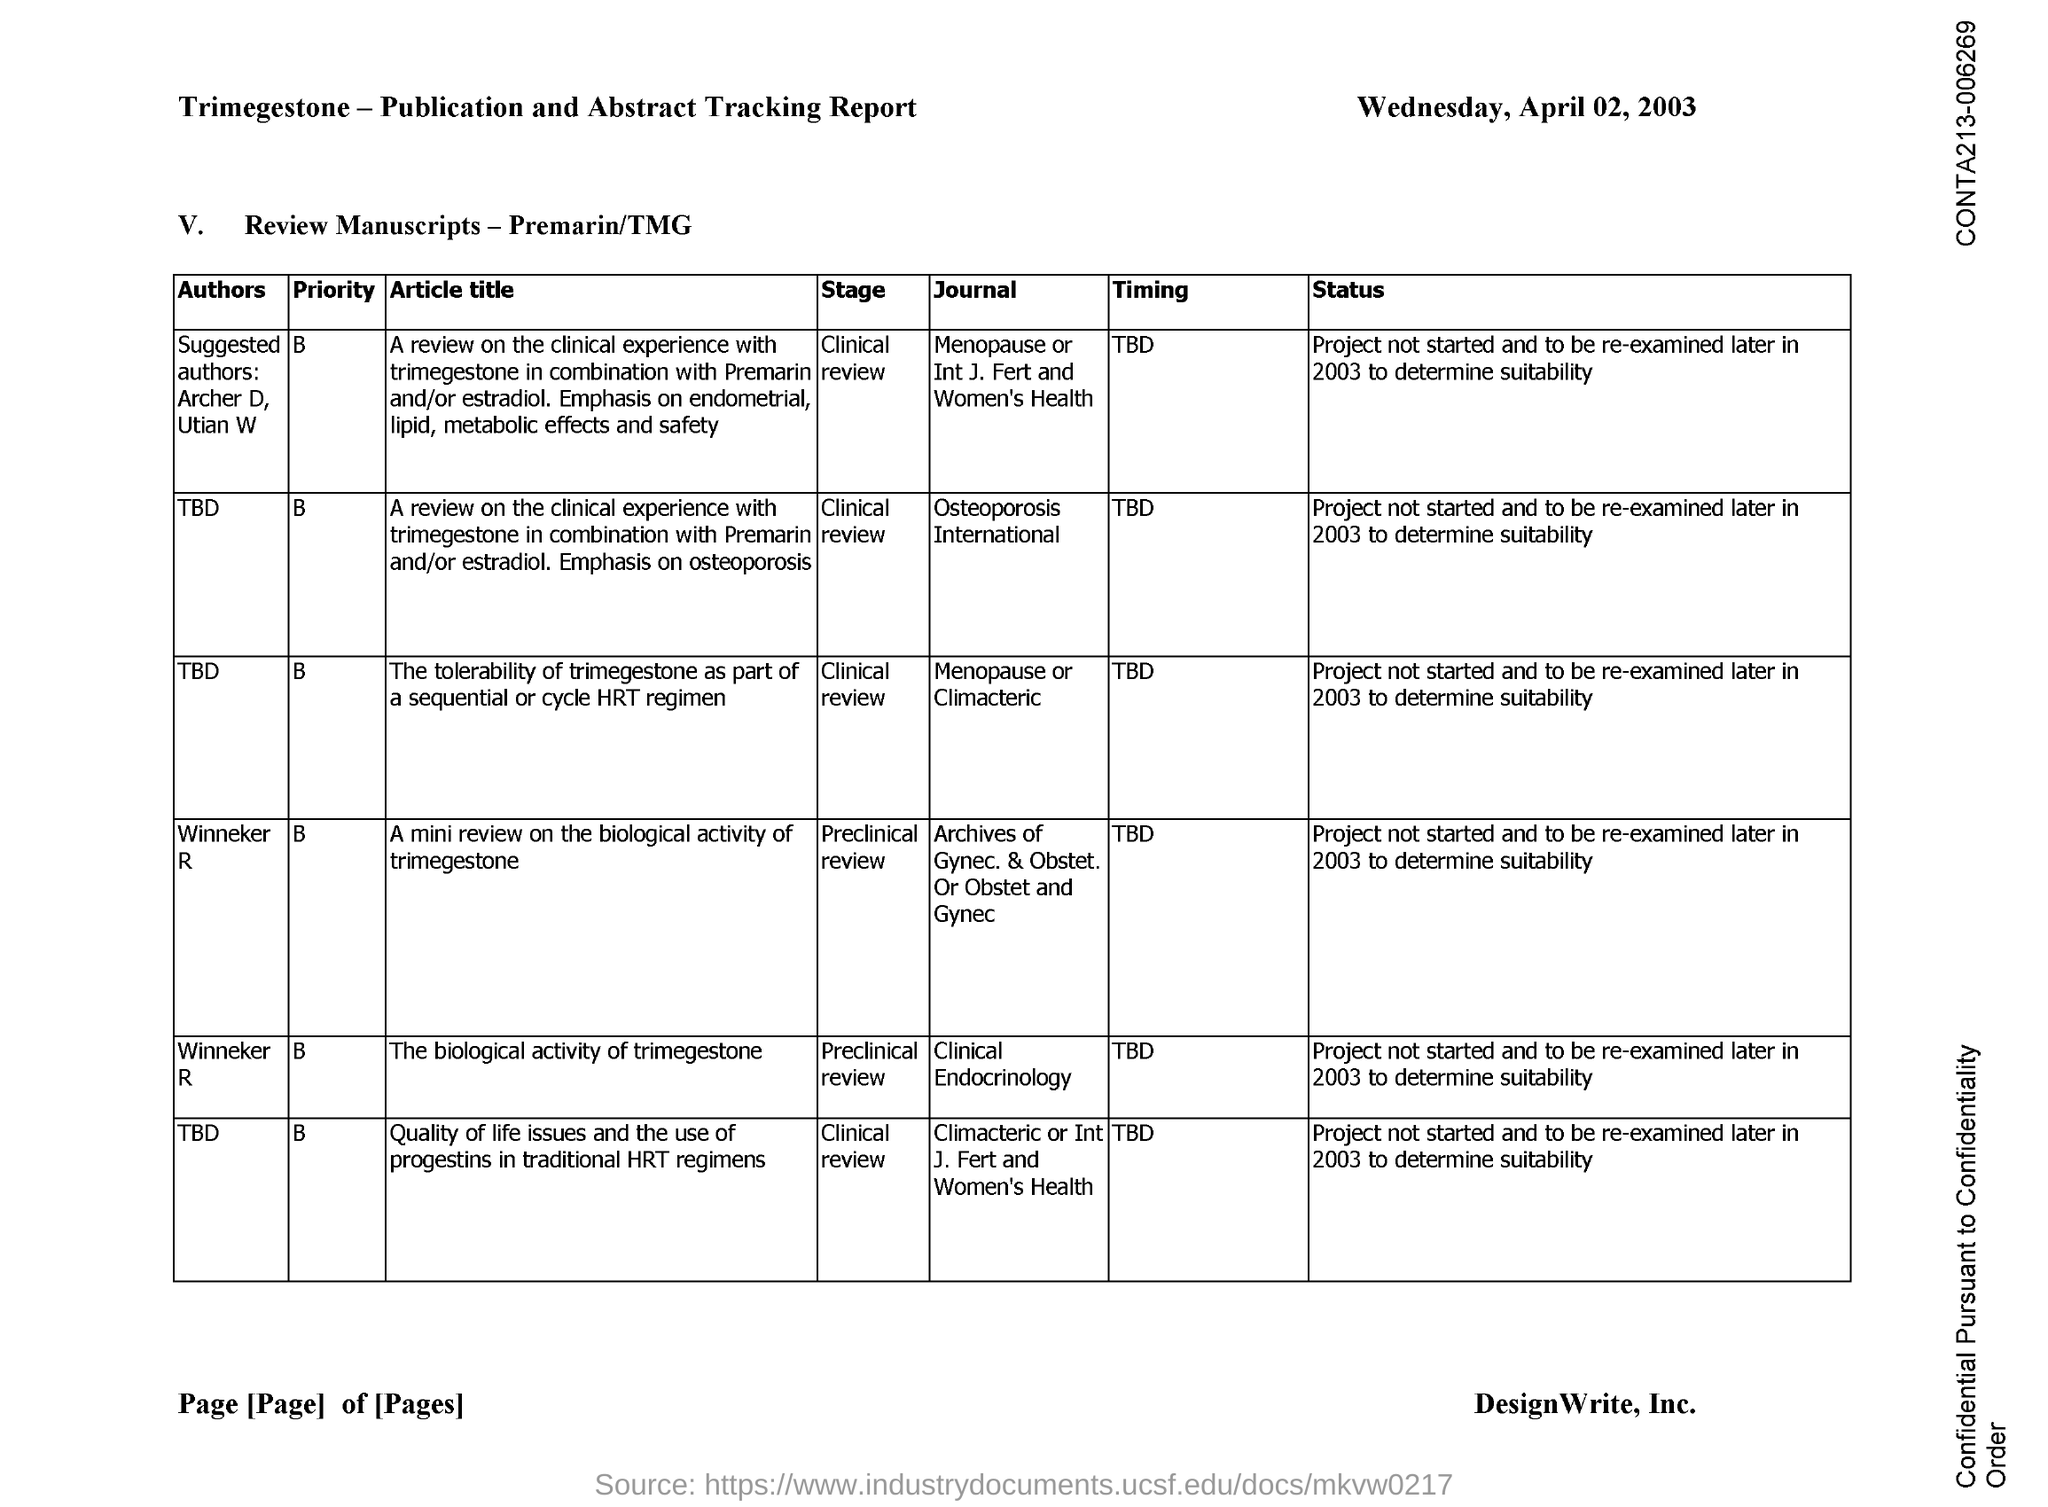When is the document dated?
Provide a succinct answer. WEDNESDAY, APRIL 02, 2003. Who is the author of the article "The biological activity of trimegestone"?
Your answer should be very brief. Winneker R. 